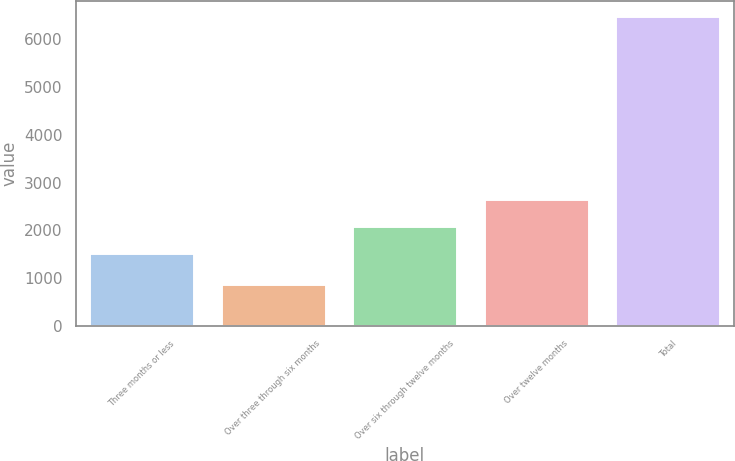<chart> <loc_0><loc_0><loc_500><loc_500><bar_chart><fcel>Three months or less<fcel>Over three through six months<fcel>Over six through twelve months<fcel>Over twelve months<fcel>Total<nl><fcel>1529<fcel>876<fcel>2088.9<fcel>2648.8<fcel>6475<nl></chart> 